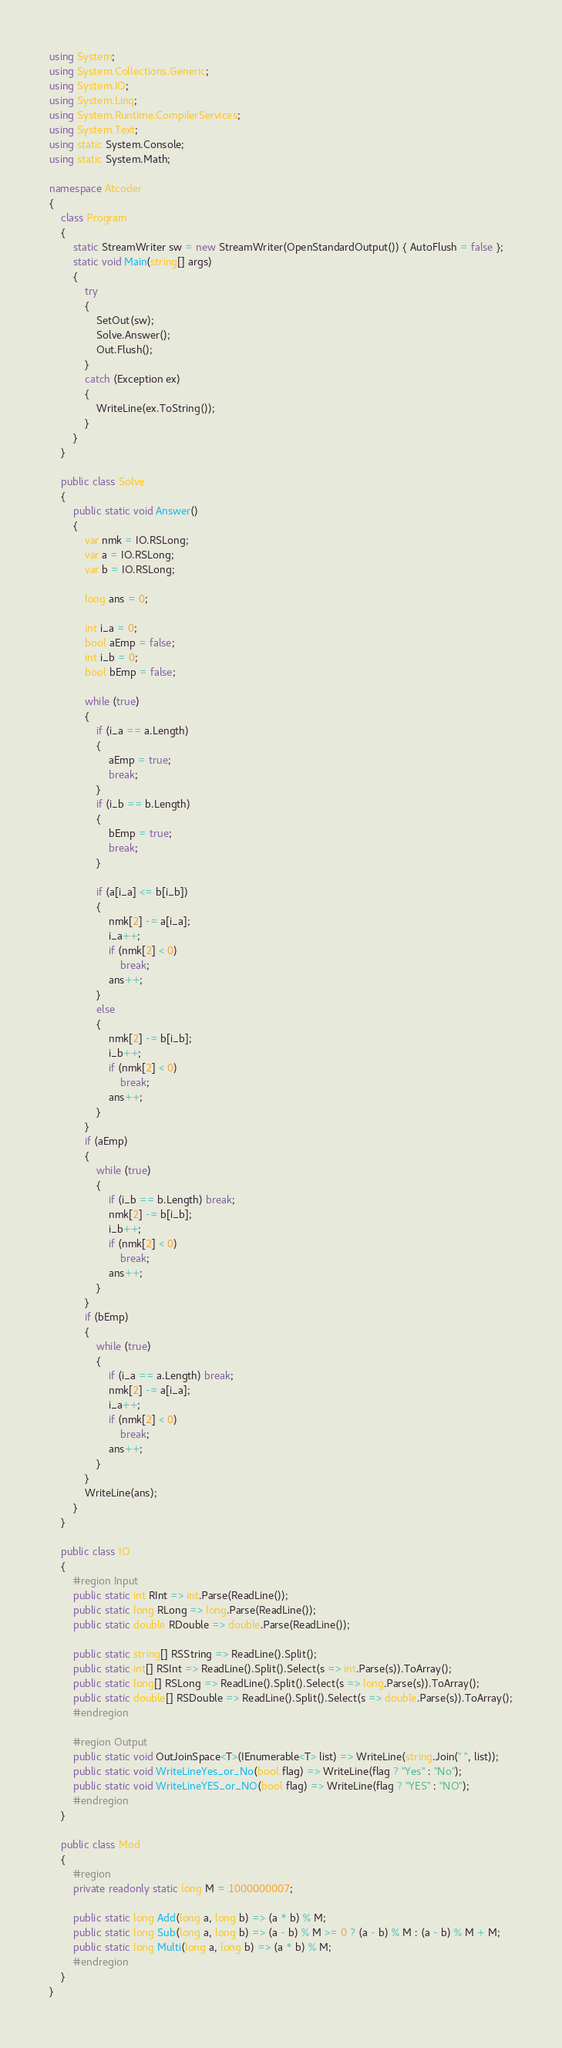<code> <loc_0><loc_0><loc_500><loc_500><_C#_>using System;
using System.Collections.Generic;
using System.IO;
using System.Linq;
using System.Runtime.CompilerServices;
using System.Text;
using static System.Console;
using static System.Math;

namespace Atcoder
{
    class Program
    {
        static StreamWriter sw = new StreamWriter(OpenStandardOutput()) { AutoFlush = false };
        static void Main(string[] args)
        {
            try
            {
                SetOut(sw);
                Solve.Answer();
                Out.Flush();
            }
            catch (Exception ex)
            {
                WriteLine(ex.ToString());
            }
        }
    }

    public class Solve
    {
        public static void Answer()
        {
            var nmk = IO.RSLong;
            var a = IO.RSLong;
            var b = IO.RSLong;

            long ans = 0;

            int i_a = 0;
            bool aEmp = false;
            int i_b = 0;
            bool bEmp = false;

            while (true)
            {
                if (i_a == a.Length)
                {
                    aEmp = true;
                    break;
                }
                if (i_b == b.Length)
                {
                    bEmp = true;
                    break;
                }

                if (a[i_a] <= b[i_b])
                {
                    nmk[2] -= a[i_a];
                    i_a++;
                    if (nmk[2] < 0)
                        break;
                    ans++;
                }
                else
                {
                    nmk[2] -= b[i_b];
                    i_b++;
                    if (nmk[2] < 0)
                        break;
                    ans++;
                }
            }
            if (aEmp)
            {
                while (true)
                {
                    if (i_b == b.Length) break;
                    nmk[2] -= b[i_b];
                    i_b++;
                    if (nmk[2] < 0)
                        break;
                    ans++;
                }
            }
            if (bEmp)
            {
                while (true)
                {
                    if (i_a == a.Length) break;
                    nmk[2] -= a[i_a];
                    i_a++;
                    if (nmk[2] < 0)
                        break;
                    ans++;
                }
            }
            WriteLine(ans);
        }
    }

    public class IO
    {
        #region Input
        public static int RInt => int.Parse(ReadLine());
        public static long RLong => long.Parse(ReadLine());
        public static double RDouble => double.Parse(ReadLine());

        public static string[] RSString => ReadLine().Split();
        public static int[] RSInt => ReadLine().Split().Select(s => int.Parse(s)).ToArray();
        public static long[] RSLong => ReadLine().Split().Select(s => long.Parse(s)).ToArray();
        public static double[] RSDouble => ReadLine().Split().Select(s => double.Parse(s)).ToArray();
        #endregion

        #region Output
        public static void OutJoinSpace<T>(IEnumerable<T> list) => WriteLine(string.Join(" ", list));
        public static void WriteLineYes_or_No(bool flag) => WriteLine(flag ? "Yes" : "No");
        public static void WriteLineYES_or_NO(bool flag) => WriteLine(flag ? "YES" : "NO");
        #endregion
    }

    public class Mod
    {
        #region
        private readonly static long M = 1000000007;

        public static long Add(long a, long b) => (a * b) % M;
        public static long Sub(long a, long b) => (a - b) % M >= 0 ? (a - b) % M : (a - b) % M + M;
        public static long Multi(long a, long b) => (a * b) % M;
        #endregion
    }
}</code> 